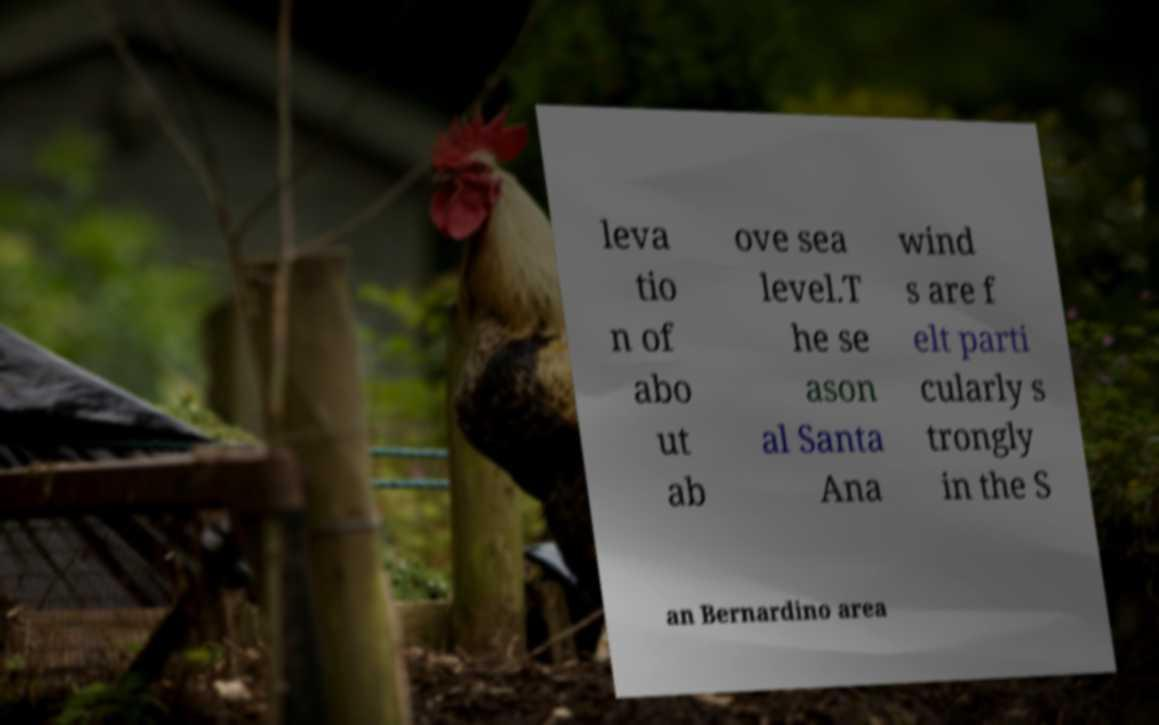I need the written content from this picture converted into text. Can you do that? leva tio n of abo ut ab ove sea level.T he se ason al Santa Ana wind s are f elt parti cularly s trongly in the S an Bernardino area 